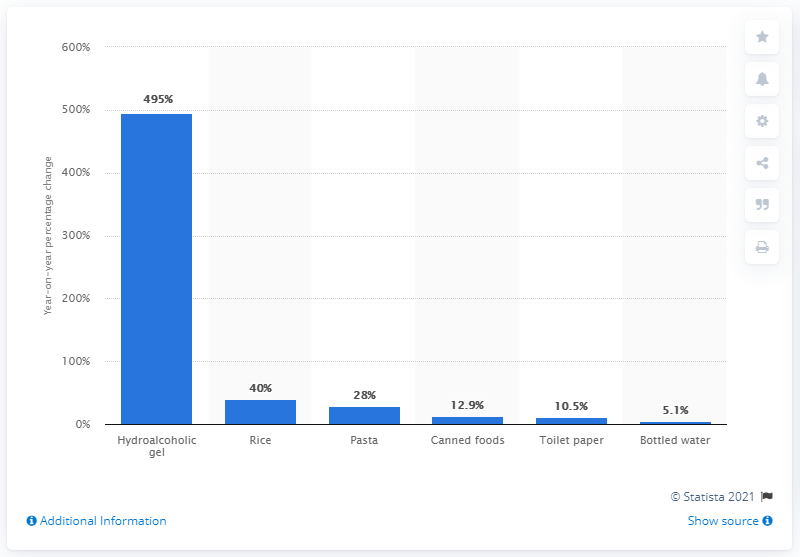Give some essential details in this illustration. Toilet paper sales in Belgium increased by 10.5% in the past year. 